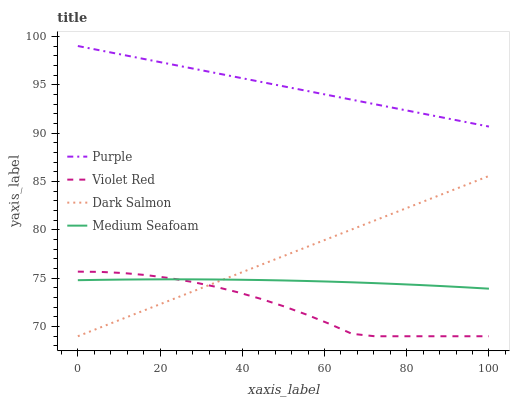Does Violet Red have the minimum area under the curve?
Answer yes or no. Yes. Does Purple have the maximum area under the curve?
Answer yes or no. Yes. Does Dark Salmon have the minimum area under the curve?
Answer yes or no. No. Does Dark Salmon have the maximum area under the curve?
Answer yes or no. No. Is Dark Salmon the smoothest?
Answer yes or no. Yes. Is Violet Red the roughest?
Answer yes or no. Yes. Is Violet Red the smoothest?
Answer yes or no. No. Is Dark Salmon the roughest?
Answer yes or no. No. Does Violet Red have the lowest value?
Answer yes or no. Yes. Does Medium Seafoam have the lowest value?
Answer yes or no. No. Does Purple have the highest value?
Answer yes or no. Yes. Does Violet Red have the highest value?
Answer yes or no. No. Is Medium Seafoam less than Purple?
Answer yes or no. Yes. Is Purple greater than Violet Red?
Answer yes or no. Yes. Does Medium Seafoam intersect Violet Red?
Answer yes or no. Yes. Is Medium Seafoam less than Violet Red?
Answer yes or no. No. Is Medium Seafoam greater than Violet Red?
Answer yes or no. No. Does Medium Seafoam intersect Purple?
Answer yes or no. No. 